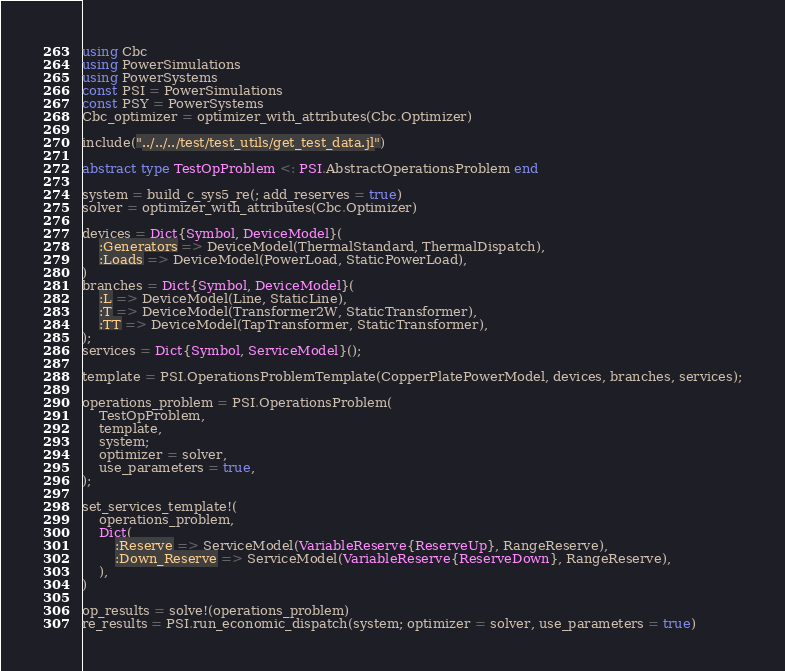<code> <loc_0><loc_0><loc_500><loc_500><_Julia_>using Cbc
using PowerSimulations
using PowerSystems
const PSI = PowerSimulations
const PSY = PowerSystems
Cbc_optimizer = optimizer_with_attributes(Cbc.Optimizer)

include("../../../test/test_utils/get_test_data.jl")

abstract type TestOpProblem <: PSI.AbstractOperationsProblem end

system = build_c_sys5_re(; add_reserves = true)
solver = optimizer_with_attributes(Cbc.Optimizer)

devices = Dict{Symbol, DeviceModel}(
    :Generators => DeviceModel(ThermalStandard, ThermalDispatch),
    :Loads => DeviceModel(PowerLoad, StaticPowerLoad),
)
branches = Dict{Symbol, DeviceModel}(
    :L => DeviceModel(Line, StaticLine),
    :T => DeviceModel(Transformer2W, StaticTransformer),
    :TT => DeviceModel(TapTransformer, StaticTransformer),
);
services = Dict{Symbol, ServiceModel}();

template = PSI.OperationsProblemTemplate(CopperPlatePowerModel, devices, branches, services);

operations_problem = PSI.OperationsProblem(
    TestOpProblem,
    template,
    system;
    optimizer = solver,
    use_parameters = true,
);

set_services_template!(
    operations_problem,
    Dict(
        :Reserve => ServiceModel(VariableReserve{ReserveUp}, RangeReserve),
        :Down_Reserve => ServiceModel(VariableReserve{ReserveDown}, RangeReserve),
    ),
)

op_results = solve!(operations_problem)
re_results = PSI.run_economic_dispatch(system; optimizer = solver, use_parameters = true)
</code> 